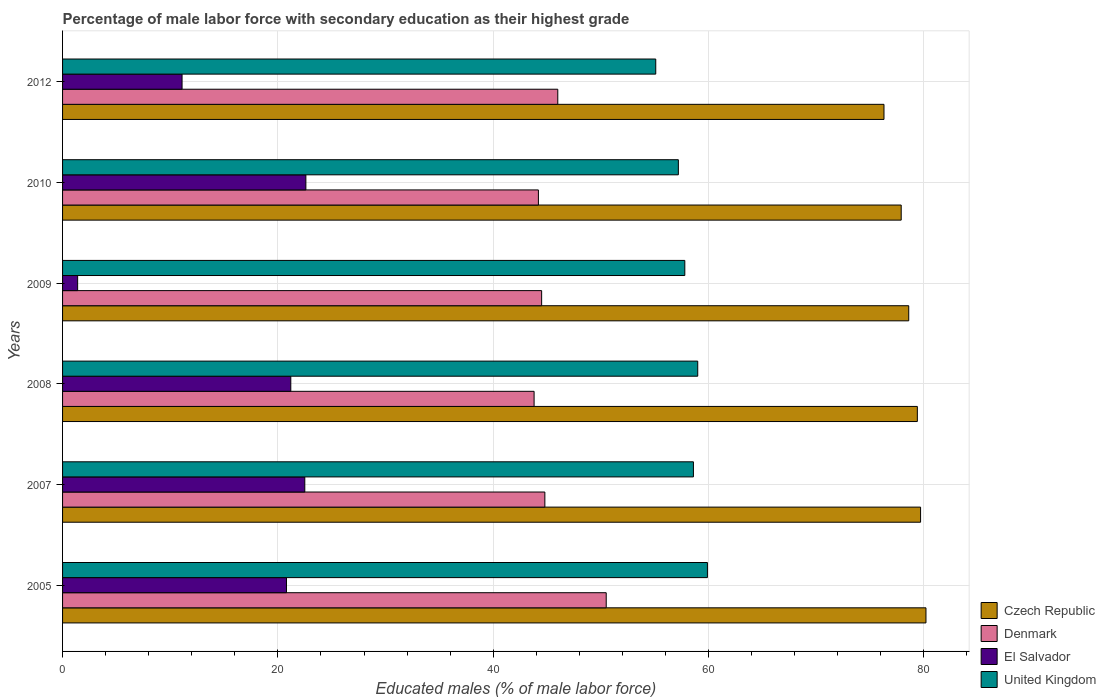How many different coloured bars are there?
Provide a short and direct response. 4. How many bars are there on the 1st tick from the top?
Your answer should be very brief. 4. How many bars are there on the 4th tick from the bottom?
Your response must be concise. 4. What is the percentage of male labor force with secondary education in El Salvador in 2010?
Make the answer very short. 22.6. Across all years, what is the maximum percentage of male labor force with secondary education in El Salvador?
Provide a succinct answer. 22.6. Across all years, what is the minimum percentage of male labor force with secondary education in Denmark?
Ensure brevity in your answer.  43.8. In which year was the percentage of male labor force with secondary education in El Salvador maximum?
Offer a terse response. 2010. What is the total percentage of male labor force with secondary education in Czech Republic in the graph?
Make the answer very short. 472.1. What is the difference between the percentage of male labor force with secondary education in El Salvador in 2005 and that in 2010?
Your answer should be very brief. -1.8. What is the difference between the percentage of male labor force with secondary education in United Kingdom in 2009 and the percentage of male labor force with secondary education in Czech Republic in 2007?
Offer a very short reply. -21.9. What is the average percentage of male labor force with secondary education in El Salvador per year?
Provide a succinct answer. 16.6. In the year 2009, what is the difference between the percentage of male labor force with secondary education in Czech Republic and percentage of male labor force with secondary education in Denmark?
Make the answer very short. 34.1. What is the ratio of the percentage of male labor force with secondary education in Denmark in 2007 to that in 2009?
Your response must be concise. 1.01. Is the difference between the percentage of male labor force with secondary education in Czech Republic in 2009 and 2010 greater than the difference between the percentage of male labor force with secondary education in Denmark in 2009 and 2010?
Your answer should be very brief. Yes. What is the difference between the highest and the lowest percentage of male labor force with secondary education in Czech Republic?
Your response must be concise. 3.9. In how many years, is the percentage of male labor force with secondary education in El Salvador greater than the average percentage of male labor force with secondary education in El Salvador taken over all years?
Provide a short and direct response. 4. Is the sum of the percentage of male labor force with secondary education in Czech Republic in 2005 and 2009 greater than the maximum percentage of male labor force with secondary education in Denmark across all years?
Give a very brief answer. Yes. Is it the case that in every year, the sum of the percentage of male labor force with secondary education in United Kingdom and percentage of male labor force with secondary education in Denmark is greater than the sum of percentage of male labor force with secondary education in El Salvador and percentage of male labor force with secondary education in Czech Republic?
Ensure brevity in your answer.  Yes. What does the 3rd bar from the top in 2010 represents?
Make the answer very short. Denmark. What does the 4th bar from the bottom in 2010 represents?
Give a very brief answer. United Kingdom. Is it the case that in every year, the sum of the percentage of male labor force with secondary education in Denmark and percentage of male labor force with secondary education in United Kingdom is greater than the percentage of male labor force with secondary education in Czech Republic?
Provide a short and direct response. Yes. How many bars are there?
Ensure brevity in your answer.  24. Are all the bars in the graph horizontal?
Offer a terse response. Yes. Are the values on the major ticks of X-axis written in scientific E-notation?
Ensure brevity in your answer.  No. Does the graph contain grids?
Keep it short and to the point. Yes. How are the legend labels stacked?
Provide a short and direct response. Vertical. What is the title of the graph?
Offer a very short reply. Percentage of male labor force with secondary education as their highest grade. What is the label or title of the X-axis?
Provide a succinct answer. Educated males (% of male labor force). What is the Educated males (% of male labor force) in Czech Republic in 2005?
Provide a succinct answer. 80.2. What is the Educated males (% of male labor force) in Denmark in 2005?
Your response must be concise. 50.5. What is the Educated males (% of male labor force) in El Salvador in 2005?
Provide a succinct answer. 20.8. What is the Educated males (% of male labor force) of United Kingdom in 2005?
Ensure brevity in your answer.  59.9. What is the Educated males (% of male labor force) in Czech Republic in 2007?
Give a very brief answer. 79.7. What is the Educated males (% of male labor force) of Denmark in 2007?
Make the answer very short. 44.8. What is the Educated males (% of male labor force) in United Kingdom in 2007?
Offer a terse response. 58.6. What is the Educated males (% of male labor force) in Czech Republic in 2008?
Make the answer very short. 79.4. What is the Educated males (% of male labor force) of Denmark in 2008?
Ensure brevity in your answer.  43.8. What is the Educated males (% of male labor force) of El Salvador in 2008?
Give a very brief answer. 21.2. What is the Educated males (% of male labor force) in United Kingdom in 2008?
Keep it short and to the point. 59. What is the Educated males (% of male labor force) in Czech Republic in 2009?
Provide a short and direct response. 78.6. What is the Educated males (% of male labor force) in Denmark in 2009?
Provide a short and direct response. 44.5. What is the Educated males (% of male labor force) in El Salvador in 2009?
Your response must be concise. 1.4. What is the Educated males (% of male labor force) of United Kingdom in 2009?
Provide a short and direct response. 57.8. What is the Educated males (% of male labor force) of Czech Republic in 2010?
Your answer should be compact. 77.9. What is the Educated males (% of male labor force) of Denmark in 2010?
Provide a succinct answer. 44.2. What is the Educated males (% of male labor force) in El Salvador in 2010?
Offer a very short reply. 22.6. What is the Educated males (% of male labor force) of United Kingdom in 2010?
Make the answer very short. 57.2. What is the Educated males (% of male labor force) of Czech Republic in 2012?
Provide a succinct answer. 76.3. What is the Educated males (% of male labor force) of Denmark in 2012?
Give a very brief answer. 46. What is the Educated males (% of male labor force) of El Salvador in 2012?
Offer a very short reply. 11.1. What is the Educated males (% of male labor force) of United Kingdom in 2012?
Keep it short and to the point. 55.1. Across all years, what is the maximum Educated males (% of male labor force) in Czech Republic?
Provide a short and direct response. 80.2. Across all years, what is the maximum Educated males (% of male labor force) of Denmark?
Provide a short and direct response. 50.5. Across all years, what is the maximum Educated males (% of male labor force) of El Salvador?
Give a very brief answer. 22.6. Across all years, what is the maximum Educated males (% of male labor force) in United Kingdom?
Your response must be concise. 59.9. Across all years, what is the minimum Educated males (% of male labor force) in Czech Republic?
Provide a short and direct response. 76.3. Across all years, what is the minimum Educated males (% of male labor force) in Denmark?
Ensure brevity in your answer.  43.8. Across all years, what is the minimum Educated males (% of male labor force) of El Salvador?
Provide a short and direct response. 1.4. Across all years, what is the minimum Educated males (% of male labor force) in United Kingdom?
Your answer should be compact. 55.1. What is the total Educated males (% of male labor force) of Czech Republic in the graph?
Your answer should be compact. 472.1. What is the total Educated males (% of male labor force) in Denmark in the graph?
Your answer should be compact. 273.8. What is the total Educated males (% of male labor force) in El Salvador in the graph?
Your answer should be very brief. 99.6. What is the total Educated males (% of male labor force) of United Kingdom in the graph?
Give a very brief answer. 347.6. What is the difference between the Educated males (% of male labor force) of Czech Republic in 2005 and that in 2007?
Your answer should be compact. 0.5. What is the difference between the Educated males (% of male labor force) of Denmark in 2005 and that in 2008?
Ensure brevity in your answer.  6.7. What is the difference between the Educated males (% of male labor force) in El Salvador in 2005 and that in 2008?
Offer a very short reply. -0.4. What is the difference between the Educated males (% of male labor force) in United Kingdom in 2005 and that in 2008?
Offer a terse response. 0.9. What is the difference between the Educated males (% of male labor force) of Denmark in 2005 and that in 2009?
Your response must be concise. 6. What is the difference between the Educated males (% of male labor force) in El Salvador in 2005 and that in 2009?
Ensure brevity in your answer.  19.4. What is the difference between the Educated males (% of male labor force) of Czech Republic in 2005 and that in 2010?
Ensure brevity in your answer.  2.3. What is the difference between the Educated males (% of male labor force) in United Kingdom in 2005 and that in 2010?
Give a very brief answer. 2.7. What is the difference between the Educated males (% of male labor force) in United Kingdom in 2005 and that in 2012?
Ensure brevity in your answer.  4.8. What is the difference between the Educated males (% of male labor force) in Denmark in 2007 and that in 2008?
Offer a terse response. 1. What is the difference between the Educated males (% of male labor force) in El Salvador in 2007 and that in 2008?
Offer a very short reply. 1.3. What is the difference between the Educated males (% of male labor force) in Czech Republic in 2007 and that in 2009?
Give a very brief answer. 1.1. What is the difference between the Educated males (% of male labor force) of El Salvador in 2007 and that in 2009?
Provide a succinct answer. 21.1. What is the difference between the Educated males (% of male labor force) of Czech Republic in 2007 and that in 2010?
Keep it short and to the point. 1.8. What is the difference between the Educated males (% of male labor force) in El Salvador in 2007 and that in 2010?
Offer a terse response. -0.1. What is the difference between the Educated males (% of male labor force) of Denmark in 2007 and that in 2012?
Make the answer very short. -1.2. What is the difference between the Educated males (% of male labor force) in United Kingdom in 2007 and that in 2012?
Keep it short and to the point. 3.5. What is the difference between the Educated males (% of male labor force) in El Salvador in 2008 and that in 2009?
Give a very brief answer. 19.8. What is the difference between the Educated males (% of male labor force) of United Kingdom in 2008 and that in 2009?
Make the answer very short. 1.2. What is the difference between the Educated males (% of male labor force) in Czech Republic in 2008 and that in 2012?
Make the answer very short. 3.1. What is the difference between the Educated males (% of male labor force) of Denmark in 2008 and that in 2012?
Your response must be concise. -2.2. What is the difference between the Educated males (% of male labor force) of El Salvador in 2009 and that in 2010?
Your answer should be very brief. -21.2. What is the difference between the Educated males (% of male labor force) of Czech Republic in 2009 and that in 2012?
Your response must be concise. 2.3. What is the difference between the Educated males (% of male labor force) of Denmark in 2010 and that in 2012?
Provide a succinct answer. -1.8. What is the difference between the Educated males (% of male labor force) of El Salvador in 2010 and that in 2012?
Make the answer very short. 11.5. What is the difference between the Educated males (% of male labor force) in Czech Republic in 2005 and the Educated males (% of male labor force) in Denmark in 2007?
Give a very brief answer. 35.4. What is the difference between the Educated males (% of male labor force) in Czech Republic in 2005 and the Educated males (% of male labor force) in El Salvador in 2007?
Provide a succinct answer. 57.7. What is the difference between the Educated males (% of male labor force) in Czech Republic in 2005 and the Educated males (% of male labor force) in United Kingdom in 2007?
Ensure brevity in your answer.  21.6. What is the difference between the Educated males (% of male labor force) of Denmark in 2005 and the Educated males (% of male labor force) of El Salvador in 2007?
Offer a terse response. 28. What is the difference between the Educated males (% of male labor force) in Denmark in 2005 and the Educated males (% of male labor force) in United Kingdom in 2007?
Offer a terse response. -8.1. What is the difference between the Educated males (% of male labor force) in El Salvador in 2005 and the Educated males (% of male labor force) in United Kingdom in 2007?
Your answer should be compact. -37.8. What is the difference between the Educated males (% of male labor force) in Czech Republic in 2005 and the Educated males (% of male labor force) in Denmark in 2008?
Give a very brief answer. 36.4. What is the difference between the Educated males (% of male labor force) in Czech Republic in 2005 and the Educated males (% of male labor force) in El Salvador in 2008?
Offer a very short reply. 59. What is the difference between the Educated males (% of male labor force) of Czech Republic in 2005 and the Educated males (% of male labor force) of United Kingdom in 2008?
Ensure brevity in your answer.  21.2. What is the difference between the Educated males (% of male labor force) of Denmark in 2005 and the Educated males (% of male labor force) of El Salvador in 2008?
Your answer should be very brief. 29.3. What is the difference between the Educated males (% of male labor force) of El Salvador in 2005 and the Educated males (% of male labor force) of United Kingdom in 2008?
Provide a short and direct response. -38.2. What is the difference between the Educated males (% of male labor force) in Czech Republic in 2005 and the Educated males (% of male labor force) in Denmark in 2009?
Offer a very short reply. 35.7. What is the difference between the Educated males (% of male labor force) of Czech Republic in 2005 and the Educated males (% of male labor force) of El Salvador in 2009?
Make the answer very short. 78.8. What is the difference between the Educated males (% of male labor force) in Czech Republic in 2005 and the Educated males (% of male labor force) in United Kingdom in 2009?
Provide a short and direct response. 22.4. What is the difference between the Educated males (% of male labor force) in Denmark in 2005 and the Educated males (% of male labor force) in El Salvador in 2009?
Offer a terse response. 49.1. What is the difference between the Educated males (% of male labor force) of Denmark in 2005 and the Educated males (% of male labor force) of United Kingdom in 2009?
Provide a short and direct response. -7.3. What is the difference between the Educated males (% of male labor force) in El Salvador in 2005 and the Educated males (% of male labor force) in United Kingdom in 2009?
Provide a short and direct response. -37. What is the difference between the Educated males (% of male labor force) in Czech Republic in 2005 and the Educated males (% of male labor force) in El Salvador in 2010?
Give a very brief answer. 57.6. What is the difference between the Educated males (% of male labor force) of Denmark in 2005 and the Educated males (% of male labor force) of El Salvador in 2010?
Give a very brief answer. 27.9. What is the difference between the Educated males (% of male labor force) of Denmark in 2005 and the Educated males (% of male labor force) of United Kingdom in 2010?
Your answer should be compact. -6.7. What is the difference between the Educated males (% of male labor force) in El Salvador in 2005 and the Educated males (% of male labor force) in United Kingdom in 2010?
Your answer should be compact. -36.4. What is the difference between the Educated males (% of male labor force) of Czech Republic in 2005 and the Educated males (% of male labor force) of Denmark in 2012?
Your response must be concise. 34.2. What is the difference between the Educated males (% of male labor force) in Czech Republic in 2005 and the Educated males (% of male labor force) in El Salvador in 2012?
Provide a succinct answer. 69.1. What is the difference between the Educated males (% of male labor force) of Czech Republic in 2005 and the Educated males (% of male labor force) of United Kingdom in 2012?
Make the answer very short. 25.1. What is the difference between the Educated males (% of male labor force) of Denmark in 2005 and the Educated males (% of male labor force) of El Salvador in 2012?
Make the answer very short. 39.4. What is the difference between the Educated males (% of male labor force) in Denmark in 2005 and the Educated males (% of male labor force) in United Kingdom in 2012?
Ensure brevity in your answer.  -4.6. What is the difference between the Educated males (% of male labor force) of El Salvador in 2005 and the Educated males (% of male labor force) of United Kingdom in 2012?
Ensure brevity in your answer.  -34.3. What is the difference between the Educated males (% of male labor force) of Czech Republic in 2007 and the Educated males (% of male labor force) of Denmark in 2008?
Your answer should be very brief. 35.9. What is the difference between the Educated males (% of male labor force) of Czech Republic in 2007 and the Educated males (% of male labor force) of El Salvador in 2008?
Offer a very short reply. 58.5. What is the difference between the Educated males (% of male labor force) in Czech Republic in 2007 and the Educated males (% of male labor force) in United Kingdom in 2008?
Give a very brief answer. 20.7. What is the difference between the Educated males (% of male labor force) in Denmark in 2007 and the Educated males (% of male labor force) in El Salvador in 2008?
Offer a very short reply. 23.6. What is the difference between the Educated males (% of male labor force) in Denmark in 2007 and the Educated males (% of male labor force) in United Kingdom in 2008?
Ensure brevity in your answer.  -14.2. What is the difference between the Educated males (% of male labor force) in El Salvador in 2007 and the Educated males (% of male labor force) in United Kingdom in 2008?
Your answer should be compact. -36.5. What is the difference between the Educated males (% of male labor force) of Czech Republic in 2007 and the Educated males (% of male labor force) of Denmark in 2009?
Provide a short and direct response. 35.2. What is the difference between the Educated males (% of male labor force) of Czech Republic in 2007 and the Educated males (% of male labor force) of El Salvador in 2009?
Keep it short and to the point. 78.3. What is the difference between the Educated males (% of male labor force) of Czech Republic in 2007 and the Educated males (% of male labor force) of United Kingdom in 2009?
Offer a terse response. 21.9. What is the difference between the Educated males (% of male labor force) in Denmark in 2007 and the Educated males (% of male labor force) in El Salvador in 2009?
Offer a terse response. 43.4. What is the difference between the Educated males (% of male labor force) of El Salvador in 2007 and the Educated males (% of male labor force) of United Kingdom in 2009?
Your answer should be compact. -35.3. What is the difference between the Educated males (% of male labor force) in Czech Republic in 2007 and the Educated males (% of male labor force) in Denmark in 2010?
Keep it short and to the point. 35.5. What is the difference between the Educated males (% of male labor force) in Czech Republic in 2007 and the Educated males (% of male labor force) in El Salvador in 2010?
Provide a short and direct response. 57.1. What is the difference between the Educated males (% of male labor force) in Czech Republic in 2007 and the Educated males (% of male labor force) in United Kingdom in 2010?
Your answer should be compact. 22.5. What is the difference between the Educated males (% of male labor force) in Denmark in 2007 and the Educated males (% of male labor force) in El Salvador in 2010?
Your answer should be very brief. 22.2. What is the difference between the Educated males (% of male labor force) of Denmark in 2007 and the Educated males (% of male labor force) of United Kingdom in 2010?
Your answer should be compact. -12.4. What is the difference between the Educated males (% of male labor force) in El Salvador in 2007 and the Educated males (% of male labor force) in United Kingdom in 2010?
Offer a very short reply. -34.7. What is the difference between the Educated males (% of male labor force) in Czech Republic in 2007 and the Educated males (% of male labor force) in Denmark in 2012?
Provide a succinct answer. 33.7. What is the difference between the Educated males (% of male labor force) in Czech Republic in 2007 and the Educated males (% of male labor force) in El Salvador in 2012?
Your answer should be very brief. 68.6. What is the difference between the Educated males (% of male labor force) in Czech Republic in 2007 and the Educated males (% of male labor force) in United Kingdom in 2012?
Provide a succinct answer. 24.6. What is the difference between the Educated males (% of male labor force) in Denmark in 2007 and the Educated males (% of male labor force) in El Salvador in 2012?
Your answer should be compact. 33.7. What is the difference between the Educated males (% of male labor force) in Denmark in 2007 and the Educated males (% of male labor force) in United Kingdom in 2012?
Give a very brief answer. -10.3. What is the difference between the Educated males (% of male labor force) in El Salvador in 2007 and the Educated males (% of male labor force) in United Kingdom in 2012?
Ensure brevity in your answer.  -32.6. What is the difference between the Educated males (% of male labor force) of Czech Republic in 2008 and the Educated males (% of male labor force) of Denmark in 2009?
Offer a very short reply. 34.9. What is the difference between the Educated males (% of male labor force) in Czech Republic in 2008 and the Educated males (% of male labor force) in United Kingdom in 2009?
Offer a terse response. 21.6. What is the difference between the Educated males (% of male labor force) of Denmark in 2008 and the Educated males (% of male labor force) of El Salvador in 2009?
Your response must be concise. 42.4. What is the difference between the Educated males (% of male labor force) in Denmark in 2008 and the Educated males (% of male labor force) in United Kingdom in 2009?
Provide a succinct answer. -14. What is the difference between the Educated males (% of male labor force) of El Salvador in 2008 and the Educated males (% of male labor force) of United Kingdom in 2009?
Give a very brief answer. -36.6. What is the difference between the Educated males (% of male labor force) of Czech Republic in 2008 and the Educated males (% of male labor force) of Denmark in 2010?
Offer a terse response. 35.2. What is the difference between the Educated males (% of male labor force) of Czech Republic in 2008 and the Educated males (% of male labor force) of El Salvador in 2010?
Make the answer very short. 56.8. What is the difference between the Educated males (% of male labor force) in Czech Republic in 2008 and the Educated males (% of male labor force) in United Kingdom in 2010?
Offer a very short reply. 22.2. What is the difference between the Educated males (% of male labor force) in Denmark in 2008 and the Educated males (% of male labor force) in El Salvador in 2010?
Give a very brief answer. 21.2. What is the difference between the Educated males (% of male labor force) in Denmark in 2008 and the Educated males (% of male labor force) in United Kingdom in 2010?
Provide a succinct answer. -13.4. What is the difference between the Educated males (% of male labor force) in El Salvador in 2008 and the Educated males (% of male labor force) in United Kingdom in 2010?
Your response must be concise. -36. What is the difference between the Educated males (% of male labor force) of Czech Republic in 2008 and the Educated males (% of male labor force) of Denmark in 2012?
Keep it short and to the point. 33.4. What is the difference between the Educated males (% of male labor force) of Czech Republic in 2008 and the Educated males (% of male labor force) of El Salvador in 2012?
Your answer should be very brief. 68.3. What is the difference between the Educated males (% of male labor force) of Czech Republic in 2008 and the Educated males (% of male labor force) of United Kingdom in 2012?
Provide a short and direct response. 24.3. What is the difference between the Educated males (% of male labor force) in Denmark in 2008 and the Educated males (% of male labor force) in El Salvador in 2012?
Your answer should be very brief. 32.7. What is the difference between the Educated males (% of male labor force) of Denmark in 2008 and the Educated males (% of male labor force) of United Kingdom in 2012?
Your answer should be compact. -11.3. What is the difference between the Educated males (% of male labor force) in El Salvador in 2008 and the Educated males (% of male labor force) in United Kingdom in 2012?
Your answer should be compact. -33.9. What is the difference between the Educated males (% of male labor force) in Czech Republic in 2009 and the Educated males (% of male labor force) in Denmark in 2010?
Offer a very short reply. 34.4. What is the difference between the Educated males (% of male labor force) in Czech Republic in 2009 and the Educated males (% of male labor force) in United Kingdom in 2010?
Your answer should be compact. 21.4. What is the difference between the Educated males (% of male labor force) in Denmark in 2009 and the Educated males (% of male labor force) in El Salvador in 2010?
Provide a succinct answer. 21.9. What is the difference between the Educated males (% of male labor force) of El Salvador in 2009 and the Educated males (% of male labor force) of United Kingdom in 2010?
Give a very brief answer. -55.8. What is the difference between the Educated males (% of male labor force) in Czech Republic in 2009 and the Educated males (% of male labor force) in Denmark in 2012?
Offer a terse response. 32.6. What is the difference between the Educated males (% of male labor force) of Czech Republic in 2009 and the Educated males (% of male labor force) of El Salvador in 2012?
Give a very brief answer. 67.5. What is the difference between the Educated males (% of male labor force) of Denmark in 2009 and the Educated males (% of male labor force) of El Salvador in 2012?
Your answer should be compact. 33.4. What is the difference between the Educated males (% of male labor force) in Denmark in 2009 and the Educated males (% of male labor force) in United Kingdom in 2012?
Make the answer very short. -10.6. What is the difference between the Educated males (% of male labor force) of El Salvador in 2009 and the Educated males (% of male labor force) of United Kingdom in 2012?
Provide a succinct answer. -53.7. What is the difference between the Educated males (% of male labor force) in Czech Republic in 2010 and the Educated males (% of male labor force) in Denmark in 2012?
Offer a very short reply. 31.9. What is the difference between the Educated males (% of male labor force) in Czech Republic in 2010 and the Educated males (% of male labor force) in El Salvador in 2012?
Ensure brevity in your answer.  66.8. What is the difference between the Educated males (% of male labor force) in Czech Republic in 2010 and the Educated males (% of male labor force) in United Kingdom in 2012?
Provide a short and direct response. 22.8. What is the difference between the Educated males (% of male labor force) in Denmark in 2010 and the Educated males (% of male labor force) in El Salvador in 2012?
Make the answer very short. 33.1. What is the difference between the Educated males (% of male labor force) of Denmark in 2010 and the Educated males (% of male labor force) of United Kingdom in 2012?
Your response must be concise. -10.9. What is the difference between the Educated males (% of male labor force) of El Salvador in 2010 and the Educated males (% of male labor force) of United Kingdom in 2012?
Provide a succinct answer. -32.5. What is the average Educated males (% of male labor force) in Czech Republic per year?
Your answer should be compact. 78.68. What is the average Educated males (% of male labor force) of Denmark per year?
Offer a very short reply. 45.63. What is the average Educated males (% of male labor force) in El Salvador per year?
Make the answer very short. 16.6. What is the average Educated males (% of male labor force) in United Kingdom per year?
Offer a terse response. 57.93. In the year 2005, what is the difference between the Educated males (% of male labor force) in Czech Republic and Educated males (% of male labor force) in Denmark?
Provide a succinct answer. 29.7. In the year 2005, what is the difference between the Educated males (% of male labor force) of Czech Republic and Educated males (% of male labor force) of El Salvador?
Provide a succinct answer. 59.4. In the year 2005, what is the difference between the Educated males (% of male labor force) in Czech Republic and Educated males (% of male labor force) in United Kingdom?
Provide a short and direct response. 20.3. In the year 2005, what is the difference between the Educated males (% of male labor force) in Denmark and Educated males (% of male labor force) in El Salvador?
Ensure brevity in your answer.  29.7. In the year 2005, what is the difference between the Educated males (% of male labor force) in Denmark and Educated males (% of male labor force) in United Kingdom?
Your answer should be compact. -9.4. In the year 2005, what is the difference between the Educated males (% of male labor force) in El Salvador and Educated males (% of male labor force) in United Kingdom?
Make the answer very short. -39.1. In the year 2007, what is the difference between the Educated males (% of male labor force) in Czech Republic and Educated males (% of male labor force) in Denmark?
Offer a very short reply. 34.9. In the year 2007, what is the difference between the Educated males (% of male labor force) in Czech Republic and Educated males (% of male labor force) in El Salvador?
Ensure brevity in your answer.  57.2. In the year 2007, what is the difference between the Educated males (% of male labor force) in Czech Republic and Educated males (% of male labor force) in United Kingdom?
Offer a terse response. 21.1. In the year 2007, what is the difference between the Educated males (% of male labor force) in Denmark and Educated males (% of male labor force) in El Salvador?
Give a very brief answer. 22.3. In the year 2007, what is the difference between the Educated males (% of male labor force) of Denmark and Educated males (% of male labor force) of United Kingdom?
Give a very brief answer. -13.8. In the year 2007, what is the difference between the Educated males (% of male labor force) of El Salvador and Educated males (% of male labor force) of United Kingdom?
Your answer should be compact. -36.1. In the year 2008, what is the difference between the Educated males (% of male labor force) of Czech Republic and Educated males (% of male labor force) of Denmark?
Provide a short and direct response. 35.6. In the year 2008, what is the difference between the Educated males (% of male labor force) of Czech Republic and Educated males (% of male labor force) of El Salvador?
Provide a succinct answer. 58.2. In the year 2008, what is the difference between the Educated males (% of male labor force) in Czech Republic and Educated males (% of male labor force) in United Kingdom?
Give a very brief answer. 20.4. In the year 2008, what is the difference between the Educated males (% of male labor force) of Denmark and Educated males (% of male labor force) of El Salvador?
Provide a short and direct response. 22.6. In the year 2008, what is the difference between the Educated males (% of male labor force) in Denmark and Educated males (% of male labor force) in United Kingdom?
Provide a succinct answer. -15.2. In the year 2008, what is the difference between the Educated males (% of male labor force) in El Salvador and Educated males (% of male labor force) in United Kingdom?
Your answer should be compact. -37.8. In the year 2009, what is the difference between the Educated males (% of male labor force) of Czech Republic and Educated males (% of male labor force) of Denmark?
Provide a short and direct response. 34.1. In the year 2009, what is the difference between the Educated males (% of male labor force) in Czech Republic and Educated males (% of male labor force) in El Salvador?
Your answer should be compact. 77.2. In the year 2009, what is the difference between the Educated males (% of male labor force) of Czech Republic and Educated males (% of male labor force) of United Kingdom?
Give a very brief answer. 20.8. In the year 2009, what is the difference between the Educated males (% of male labor force) in Denmark and Educated males (% of male labor force) in El Salvador?
Provide a short and direct response. 43.1. In the year 2009, what is the difference between the Educated males (% of male labor force) of El Salvador and Educated males (% of male labor force) of United Kingdom?
Your answer should be compact. -56.4. In the year 2010, what is the difference between the Educated males (% of male labor force) in Czech Republic and Educated males (% of male labor force) in Denmark?
Ensure brevity in your answer.  33.7. In the year 2010, what is the difference between the Educated males (% of male labor force) in Czech Republic and Educated males (% of male labor force) in El Salvador?
Ensure brevity in your answer.  55.3. In the year 2010, what is the difference between the Educated males (% of male labor force) of Czech Republic and Educated males (% of male labor force) of United Kingdom?
Provide a short and direct response. 20.7. In the year 2010, what is the difference between the Educated males (% of male labor force) in Denmark and Educated males (% of male labor force) in El Salvador?
Make the answer very short. 21.6. In the year 2010, what is the difference between the Educated males (% of male labor force) of Denmark and Educated males (% of male labor force) of United Kingdom?
Offer a very short reply. -13. In the year 2010, what is the difference between the Educated males (% of male labor force) of El Salvador and Educated males (% of male labor force) of United Kingdom?
Your response must be concise. -34.6. In the year 2012, what is the difference between the Educated males (% of male labor force) of Czech Republic and Educated males (% of male labor force) of Denmark?
Offer a very short reply. 30.3. In the year 2012, what is the difference between the Educated males (% of male labor force) in Czech Republic and Educated males (% of male labor force) in El Salvador?
Provide a short and direct response. 65.2. In the year 2012, what is the difference between the Educated males (% of male labor force) of Czech Republic and Educated males (% of male labor force) of United Kingdom?
Your answer should be very brief. 21.2. In the year 2012, what is the difference between the Educated males (% of male labor force) of Denmark and Educated males (% of male labor force) of El Salvador?
Keep it short and to the point. 34.9. In the year 2012, what is the difference between the Educated males (% of male labor force) of El Salvador and Educated males (% of male labor force) of United Kingdom?
Your response must be concise. -44. What is the ratio of the Educated males (% of male labor force) of Denmark in 2005 to that in 2007?
Ensure brevity in your answer.  1.13. What is the ratio of the Educated males (% of male labor force) in El Salvador in 2005 to that in 2007?
Make the answer very short. 0.92. What is the ratio of the Educated males (% of male labor force) in United Kingdom in 2005 to that in 2007?
Your response must be concise. 1.02. What is the ratio of the Educated males (% of male labor force) of Denmark in 2005 to that in 2008?
Provide a succinct answer. 1.15. What is the ratio of the Educated males (% of male labor force) of El Salvador in 2005 to that in 2008?
Your answer should be very brief. 0.98. What is the ratio of the Educated males (% of male labor force) in United Kingdom in 2005 to that in 2008?
Provide a short and direct response. 1.02. What is the ratio of the Educated males (% of male labor force) in Czech Republic in 2005 to that in 2009?
Your response must be concise. 1.02. What is the ratio of the Educated males (% of male labor force) in Denmark in 2005 to that in 2009?
Ensure brevity in your answer.  1.13. What is the ratio of the Educated males (% of male labor force) of El Salvador in 2005 to that in 2009?
Provide a succinct answer. 14.86. What is the ratio of the Educated males (% of male labor force) of United Kingdom in 2005 to that in 2009?
Your answer should be compact. 1.04. What is the ratio of the Educated males (% of male labor force) in Czech Republic in 2005 to that in 2010?
Keep it short and to the point. 1.03. What is the ratio of the Educated males (% of male labor force) of Denmark in 2005 to that in 2010?
Your answer should be compact. 1.14. What is the ratio of the Educated males (% of male labor force) of El Salvador in 2005 to that in 2010?
Give a very brief answer. 0.92. What is the ratio of the Educated males (% of male labor force) of United Kingdom in 2005 to that in 2010?
Keep it short and to the point. 1.05. What is the ratio of the Educated males (% of male labor force) of Czech Republic in 2005 to that in 2012?
Your answer should be very brief. 1.05. What is the ratio of the Educated males (% of male labor force) of Denmark in 2005 to that in 2012?
Ensure brevity in your answer.  1.1. What is the ratio of the Educated males (% of male labor force) of El Salvador in 2005 to that in 2012?
Your answer should be compact. 1.87. What is the ratio of the Educated males (% of male labor force) of United Kingdom in 2005 to that in 2012?
Ensure brevity in your answer.  1.09. What is the ratio of the Educated males (% of male labor force) in Czech Republic in 2007 to that in 2008?
Your answer should be compact. 1. What is the ratio of the Educated males (% of male labor force) in Denmark in 2007 to that in 2008?
Your answer should be compact. 1.02. What is the ratio of the Educated males (% of male labor force) in El Salvador in 2007 to that in 2008?
Your answer should be compact. 1.06. What is the ratio of the Educated males (% of male labor force) in Czech Republic in 2007 to that in 2009?
Offer a terse response. 1.01. What is the ratio of the Educated males (% of male labor force) in El Salvador in 2007 to that in 2009?
Provide a short and direct response. 16.07. What is the ratio of the Educated males (% of male labor force) of United Kingdom in 2007 to that in 2009?
Your response must be concise. 1.01. What is the ratio of the Educated males (% of male labor force) of Czech Republic in 2007 to that in 2010?
Provide a short and direct response. 1.02. What is the ratio of the Educated males (% of male labor force) of Denmark in 2007 to that in 2010?
Ensure brevity in your answer.  1.01. What is the ratio of the Educated males (% of male labor force) in El Salvador in 2007 to that in 2010?
Keep it short and to the point. 1. What is the ratio of the Educated males (% of male labor force) in United Kingdom in 2007 to that in 2010?
Your answer should be compact. 1.02. What is the ratio of the Educated males (% of male labor force) of Czech Republic in 2007 to that in 2012?
Make the answer very short. 1.04. What is the ratio of the Educated males (% of male labor force) of Denmark in 2007 to that in 2012?
Keep it short and to the point. 0.97. What is the ratio of the Educated males (% of male labor force) of El Salvador in 2007 to that in 2012?
Provide a succinct answer. 2.03. What is the ratio of the Educated males (% of male labor force) in United Kingdom in 2007 to that in 2012?
Your answer should be compact. 1.06. What is the ratio of the Educated males (% of male labor force) of Czech Republic in 2008 to that in 2009?
Your response must be concise. 1.01. What is the ratio of the Educated males (% of male labor force) in Denmark in 2008 to that in 2009?
Make the answer very short. 0.98. What is the ratio of the Educated males (% of male labor force) in El Salvador in 2008 to that in 2009?
Offer a terse response. 15.14. What is the ratio of the Educated males (% of male labor force) of United Kingdom in 2008 to that in 2009?
Offer a terse response. 1.02. What is the ratio of the Educated males (% of male labor force) in Czech Republic in 2008 to that in 2010?
Make the answer very short. 1.02. What is the ratio of the Educated males (% of male labor force) of El Salvador in 2008 to that in 2010?
Offer a very short reply. 0.94. What is the ratio of the Educated males (% of male labor force) of United Kingdom in 2008 to that in 2010?
Ensure brevity in your answer.  1.03. What is the ratio of the Educated males (% of male labor force) in Czech Republic in 2008 to that in 2012?
Offer a terse response. 1.04. What is the ratio of the Educated males (% of male labor force) of Denmark in 2008 to that in 2012?
Your answer should be compact. 0.95. What is the ratio of the Educated males (% of male labor force) in El Salvador in 2008 to that in 2012?
Give a very brief answer. 1.91. What is the ratio of the Educated males (% of male labor force) of United Kingdom in 2008 to that in 2012?
Offer a very short reply. 1.07. What is the ratio of the Educated males (% of male labor force) in Czech Republic in 2009 to that in 2010?
Your response must be concise. 1.01. What is the ratio of the Educated males (% of male labor force) of Denmark in 2009 to that in 2010?
Offer a terse response. 1.01. What is the ratio of the Educated males (% of male labor force) of El Salvador in 2009 to that in 2010?
Your answer should be compact. 0.06. What is the ratio of the Educated males (% of male labor force) in United Kingdom in 2009 to that in 2010?
Ensure brevity in your answer.  1.01. What is the ratio of the Educated males (% of male labor force) of Czech Republic in 2009 to that in 2012?
Ensure brevity in your answer.  1.03. What is the ratio of the Educated males (% of male labor force) in Denmark in 2009 to that in 2012?
Your answer should be compact. 0.97. What is the ratio of the Educated males (% of male labor force) in El Salvador in 2009 to that in 2012?
Your answer should be very brief. 0.13. What is the ratio of the Educated males (% of male labor force) of United Kingdom in 2009 to that in 2012?
Your response must be concise. 1.05. What is the ratio of the Educated males (% of male labor force) in Denmark in 2010 to that in 2012?
Offer a terse response. 0.96. What is the ratio of the Educated males (% of male labor force) in El Salvador in 2010 to that in 2012?
Provide a short and direct response. 2.04. What is the ratio of the Educated males (% of male labor force) in United Kingdom in 2010 to that in 2012?
Offer a very short reply. 1.04. What is the difference between the highest and the second highest Educated males (% of male labor force) of Czech Republic?
Your answer should be compact. 0.5. What is the difference between the highest and the second highest Educated males (% of male labor force) in Denmark?
Provide a succinct answer. 4.5. What is the difference between the highest and the second highest Educated males (% of male labor force) of El Salvador?
Your answer should be very brief. 0.1. What is the difference between the highest and the second highest Educated males (% of male labor force) of United Kingdom?
Keep it short and to the point. 0.9. What is the difference between the highest and the lowest Educated males (% of male labor force) in Czech Republic?
Ensure brevity in your answer.  3.9. What is the difference between the highest and the lowest Educated males (% of male labor force) of El Salvador?
Ensure brevity in your answer.  21.2. 